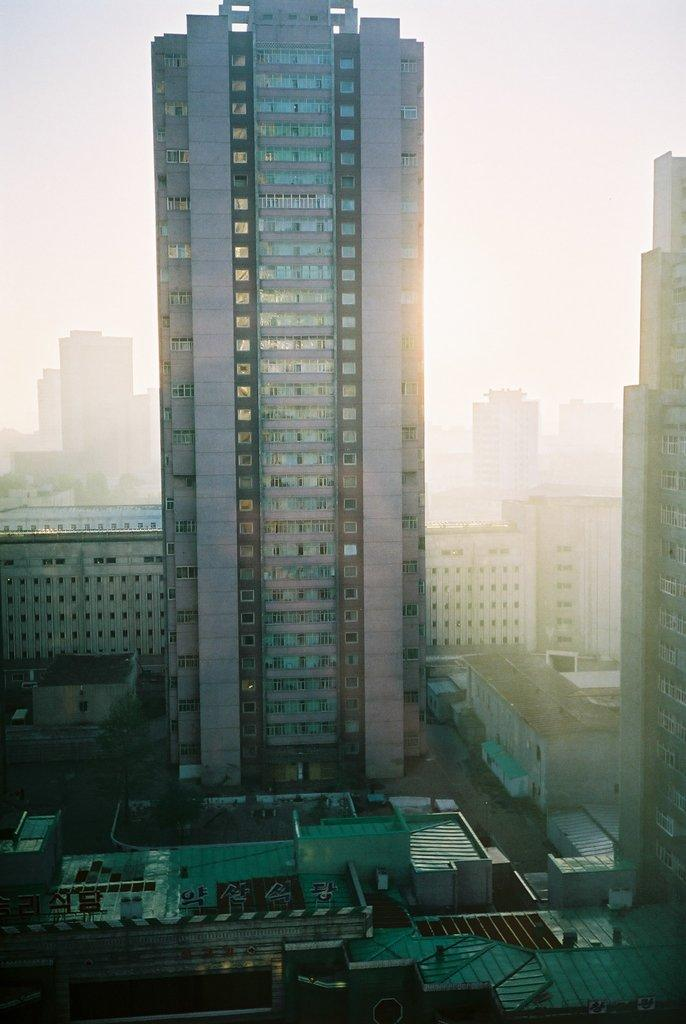What is the main subject of the image? There is a huge building in the center of the image. How are the smaller buildings arranged in relation to the huge building? The smaller buildings are surrounding the huge building. What can be seen at the top of the image? The sky is visible at the top of the image. Reasoning: Let' Let's think step by step in order to produce the conversation. We start by identifying the main subject of the image, which is the huge building. Then, we describe the relationship between the huge building and the smaller buildings surrounding it. Finally, we mention the sky visible at the top of the image to provide context about the setting. Absurd Question/Answer: How many sisters can be seen in the image? There are no sisters present in the image; it features a huge building surrounded by smaller buildings and the sky. What type of bridge is visible in the image? There is no bridge present in the image. 